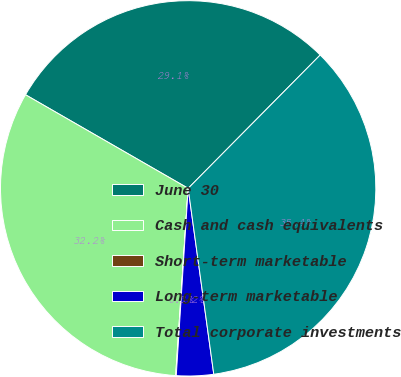<chart> <loc_0><loc_0><loc_500><loc_500><pie_chart><fcel>June 30<fcel>Cash and cash equivalents<fcel>Short-term marketable<fcel>Long-term marketable<fcel>Total corporate investments<nl><fcel>29.11%<fcel>32.25%<fcel>0.05%<fcel>3.19%<fcel>35.4%<nl></chart> 